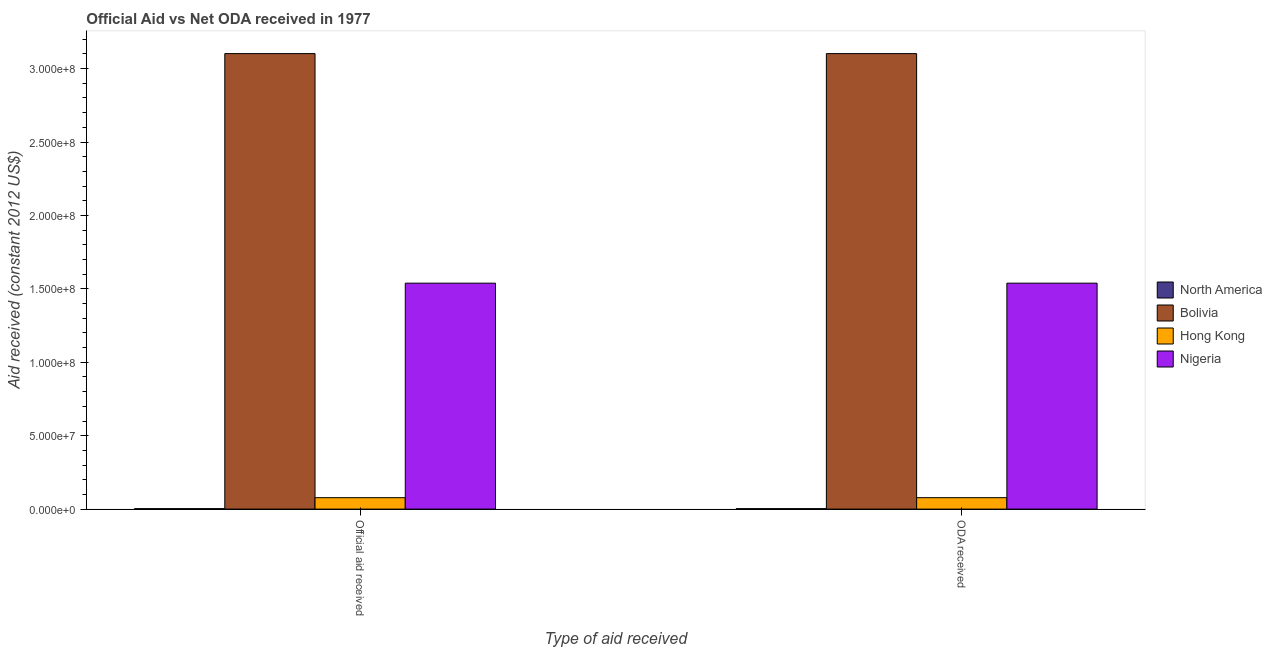Are the number of bars per tick equal to the number of legend labels?
Your answer should be compact. Yes. How many bars are there on the 1st tick from the right?
Offer a very short reply. 4. What is the label of the 2nd group of bars from the left?
Make the answer very short. ODA received. What is the official aid received in Bolivia?
Your answer should be compact. 3.10e+08. Across all countries, what is the maximum oda received?
Offer a very short reply. 3.10e+08. Across all countries, what is the minimum oda received?
Your answer should be very brief. 3.00e+05. In which country was the official aid received minimum?
Provide a succinct answer. North America. What is the total official aid received in the graph?
Your response must be concise. 4.72e+08. What is the difference between the oda received in Nigeria and that in Bolivia?
Keep it short and to the point. -1.56e+08. What is the difference between the official aid received in Nigeria and the oda received in Hong Kong?
Provide a short and direct response. 1.46e+08. What is the average oda received per country?
Offer a terse response. 1.18e+08. What is the ratio of the official aid received in Bolivia to that in Hong Kong?
Provide a succinct answer. 39.87. In how many countries, is the oda received greater than the average oda received taken over all countries?
Make the answer very short. 2. What does the 4th bar from the left in Official aid received represents?
Your answer should be compact. Nigeria. Are all the bars in the graph horizontal?
Give a very brief answer. No. How many legend labels are there?
Your answer should be very brief. 4. How are the legend labels stacked?
Provide a short and direct response. Vertical. What is the title of the graph?
Ensure brevity in your answer.  Official Aid vs Net ODA received in 1977 . What is the label or title of the X-axis?
Your answer should be compact. Type of aid received. What is the label or title of the Y-axis?
Your answer should be very brief. Aid received (constant 2012 US$). What is the Aid received (constant 2012 US$) in North America in Official aid received?
Your answer should be very brief. 3.00e+05. What is the Aid received (constant 2012 US$) in Bolivia in Official aid received?
Offer a terse response. 3.10e+08. What is the Aid received (constant 2012 US$) of Hong Kong in Official aid received?
Provide a succinct answer. 7.78e+06. What is the Aid received (constant 2012 US$) in Nigeria in Official aid received?
Offer a terse response. 1.54e+08. What is the Aid received (constant 2012 US$) of North America in ODA received?
Offer a terse response. 3.00e+05. What is the Aid received (constant 2012 US$) in Bolivia in ODA received?
Give a very brief answer. 3.10e+08. What is the Aid received (constant 2012 US$) of Hong Kong in ODA received?
Provide a succinct answer. 7.78e+06. What is the Aid received (constant 2012 US$) in Nigeria in ODA received?
Give a very brief answer. 1.54e+08. Across all Type of aid received, what is the maximum Aid received (constant 2012 US$) in Bolivia?
Ensure brevity in your answer.  3.10e+08. Across all Type of aid received, what is the maximum Aid received (constant 2012 US$) in Hong Kong?
Offer a very short reply. 7.78e+06. Across all Type of aid received, what is the maximum Aid received (constant 2012 US$) of Nigeria?
Your answer should be compact. 1.54e+08. Across all Type of aid received, what is the minimum Aid received (constant 2012 US$) in North America?
Your answer should be compact. 3.00e+05. Across all Type of aid received, what is the minimum Aid received (constant 2012 US$) in Bolivia?
Ensure brevity in your answer.  3.10e+08. Across all Type of aid received, what is the minimum Aid received (constant 2012 US$) of Hong Kong?
Give a very brief answer. 7.78e+06. Across all Type of aid received, what is the minimum Aid received (constant 2012 US$) of Nigeria?
Give a very brief answer. 1.54e+08. What is the total Aid received (constant 2012 US$) of Bolivia in the graph?
Your response must be concise. 6.20e+08. What is the total Aid received (constant 2012 US$) of Hong Kong in the graph?
Offer a terse response. 1.56e+07. What is the total Aid received (constant 2012 US$) in Nigeria in the graph?
Offer a terse response. 3.08e+08. What is the difference between the Aid received (constant 2012 US$) in Nigeria in Official aid received and that in ODA received?
Your response must be concise. 0. What is the difference between the Aid received (constant 2012 US$) in North America in Official aid received and the Aid received (constant 2012 US$) in Bolivia in ODA received?
Keep it short and to the point. -3.10e+08. What is the difference between the Aid received (constant 2012 US$) of North America in Official aid received and the Aid received (constant 2012 US$) of Hong Kong in ODA received?
Your answer should be compact. -7.48e+06. What is the difference between the Aid received (constant 2012 US$) in North America in Official aid received and the Aid received (constant 2012 US$) in Nigeria in ODA received?
Give a very brief answer. -1.54e+08. What is the difference between the Aid received (constant 2012 US$) of Bolivia in Official aid received and the Aid received (constant 2012 US$) of Hong Kong in ODA received?
Keep it short and to the point. 3.02e+08. What is the difference between the Aid received (constant 2012 US$) in Bolivia in Official aid received and the Aid received (constant 2012 US$) in Nigeria in ODA received?
Keep it short and to the point. 1.56e+08. What is the difference between the Aid received (constant 2012 US$) of Hong Kong in Official aid received and the Aid received (constant 2012 US$) of Nigeria in ODA received?
Your answer should be very brief. -1.46e+08. What is the average Aid received (constant 2012 US$) in Bolivia per Type of aid received?
Provide a short and direct response. 3.10e+08. What is the average Aid received (constant 2012 US$) in Hong Kong per Type of aid received?
Offer a terse response. 7.78e+06. What is the average Aid received (constant 2012 US$) of Nigeria per Type of aid received?
Offer a terse response. 1.54e+08. What is the difference between the Aid received (constant 2012 US$) of North America and Aid received (constant 2012 US$) of Bolivia in Official aid received?
Your answer should be very brief. -3.10e+08. What is the difference between the Aid received (constant 2012 US$) in North America and Aid received (constant 2012 US$) in Hong Kong in Official aid received?
Offer a terse response. -7.48e+06. What is the difference between the Aid received (constant 2012 US$) of North America and Aid received (constant 2012 US$) of Nigeria in Official aid received?
Offer a very short reply. -1.54e+08. What is the difference between the Aid received (constant 2012 US$) of Bolivia and Aid received (constant 2012 US$) of Hong Kong in Official aid received?
Offer a very short reply. 3.02e+08. What is the difference between the Aid received (constant 2012 US$) in Bolivia and Aid received (constant 2012 US$) in Nigeria in Official aid received?
Ensure brevity in your answer.  1.56e+08. What is the difference between the Aid received (constant 2012 US$) in Hong Kong and Aid received (constant 2012 US$) in Nigeria in Official aid received?
Provide a succinct answer. -1.46e+08. What is the difference between the Aid received (constant 2012 US$) in North America and Aid received (constant 2012 US$) in Bolivia in ODA received?
Your response must be concise. -3.10e+08. What is the difference between the Aid received (constant 2012 US$) of North America and Aid received (constant 2012 US$) of Hong Kong in ODA received?
Your response must be concise. -7.48e+06. What is the difference between the Aid received (constant 2012 US$) of North America and Aid received (constant 2012 US$) of Nigeria in ODA received?
Provide a short and direct response. -1.54e+08. What is the difference between the Aid received (constant 2012 US$) in Bolivia and Aid received (constant 2012 US$) in Hong Kong in ODA received?
Offer a very short reply. 3.02e+08. What is the difference between the Aid received (constant 2012 US$) of Bolivia and Aid received (constant 2012 US$) of Nigeria in ODA received?
Your answer should be compact. 1.56e+08. What is the difference between the Aid received (constant 2012 US$) of Hong Kong and Aid received (constant 2012 US$) of Nigeria in ODA received?
Offer a terse response. -1.46e+08. What is the ratio of the Aid received (constant 2012 US$) in North America in Official aid received to that in ODA received?
Provide a short and direct response. 1. What is the difference between the highest and the second highest Aid received (constant 2012 US$) in Bolivia?
Your response must be concise. 0. What is the difference between the highest and the second highest Aid received (constant 2012 US$) of Hong Kong?
Give a very brief answer. 0. What is the difference between the highest and the second highest Aid received (constant 2012 US$) in Nigeria?
Offer a very short reply. 0. What is the difference between the highest and the lowest Aid received (constant 2012 US$) of North America?
Ensure brevity in your answer.  0. What is the difference between the highest and the lowest Aid received (constant 2012 US$) in Bolivia?
Ensure brevity in your answer.  0. What is the difference between the highest and the lowest Aid received (constant 2012 US$) in Hong Kong?
Give a very brief answer. 0. What is the difference between the highest and the lowest Aid received (constant 2012 US$) of Nigeria?
Provide a succinct answer. 0. 